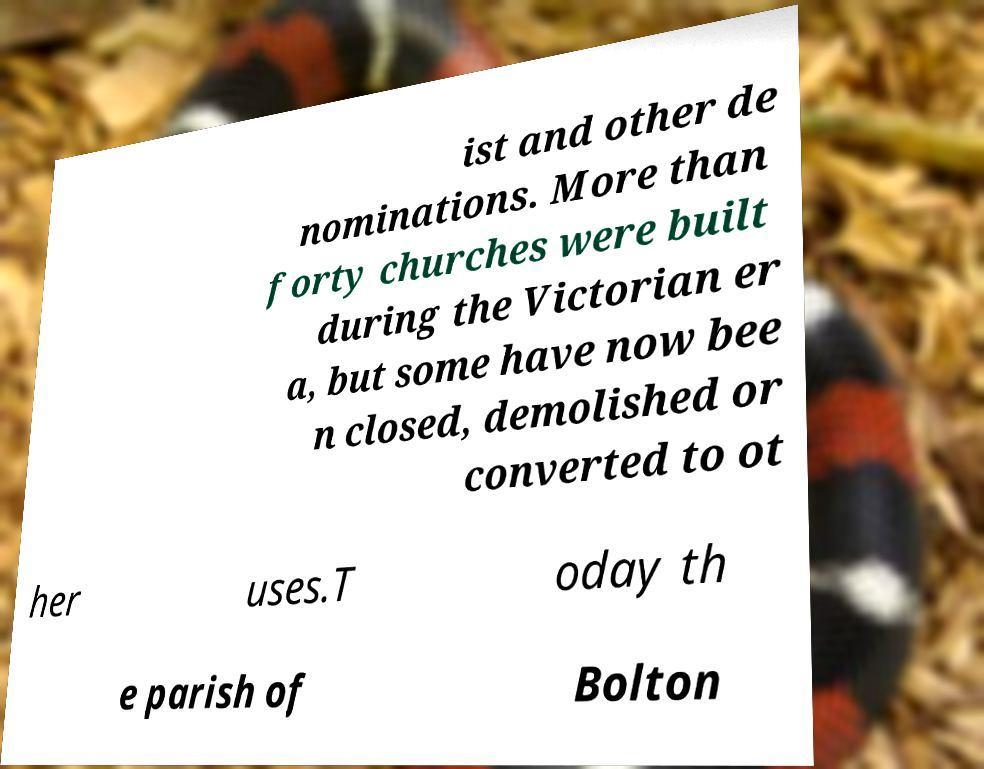What messages or text are displayed in this image? I need them in a readable, typed format. ist and other de nominations. More than forty churches were built during the Victorian er a, but some have now bee n closed, demolished or converted to ot her uses.T oday th e parish of Bolton 